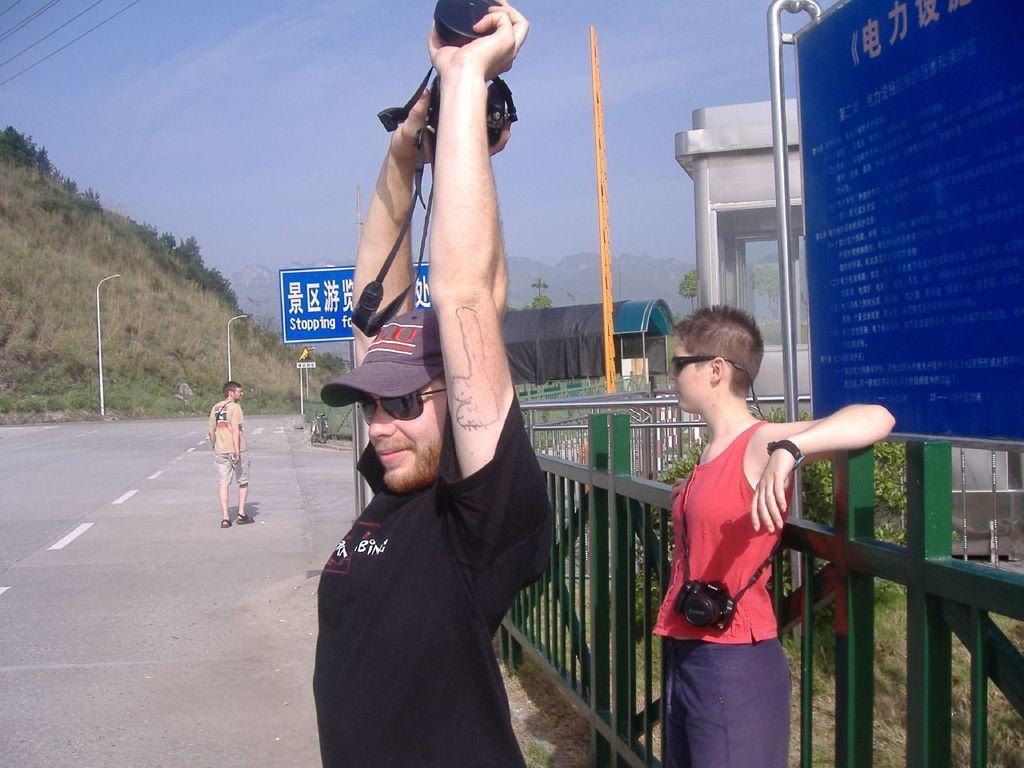Can you describe this image briefly? In this image I can see two persons visible in front of fence, one person holding an object and there is a board and plant and a person walking on the road, there is the sky, the sign board visible int eh middle and there is small tent house visible in the middle. 